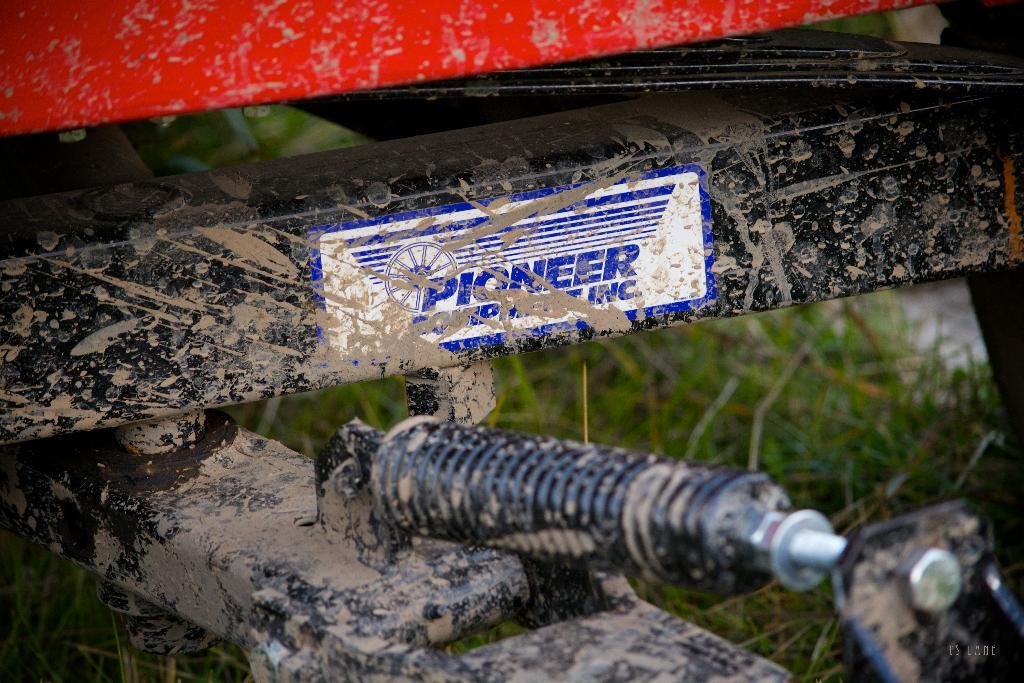What is on the metal object in the image? There is a sticker on a metal object in the image. What can be seen in the background of the image? There is grass visible in the background of the image. What is the profit of the nation depicted in the image? There is no nation depicted in the image, and therefore no information about its profit can be determined. How many minutes does the sticker remain on the metal object in the image? The duration of time the sticker remains on the metal object cannot be determined from the image. 